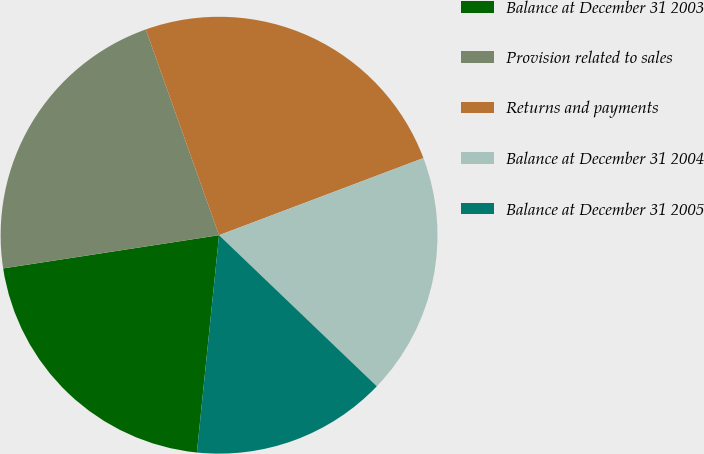Convert chart. <chart><loc_0><loc_0><loc_500><loc_500><pie_chart><fcel>Balance at December 31 2003<fcel>Provision related to sales<fcel>Returns and payments<fcel>Balance at December 31 2004<fcel>Balance at December 31 2005<nl><fcel>20.95%<fcel>21.98%<fcel>24.7%<fcel>17.9%<fcel>14.46%<nl></chart> 